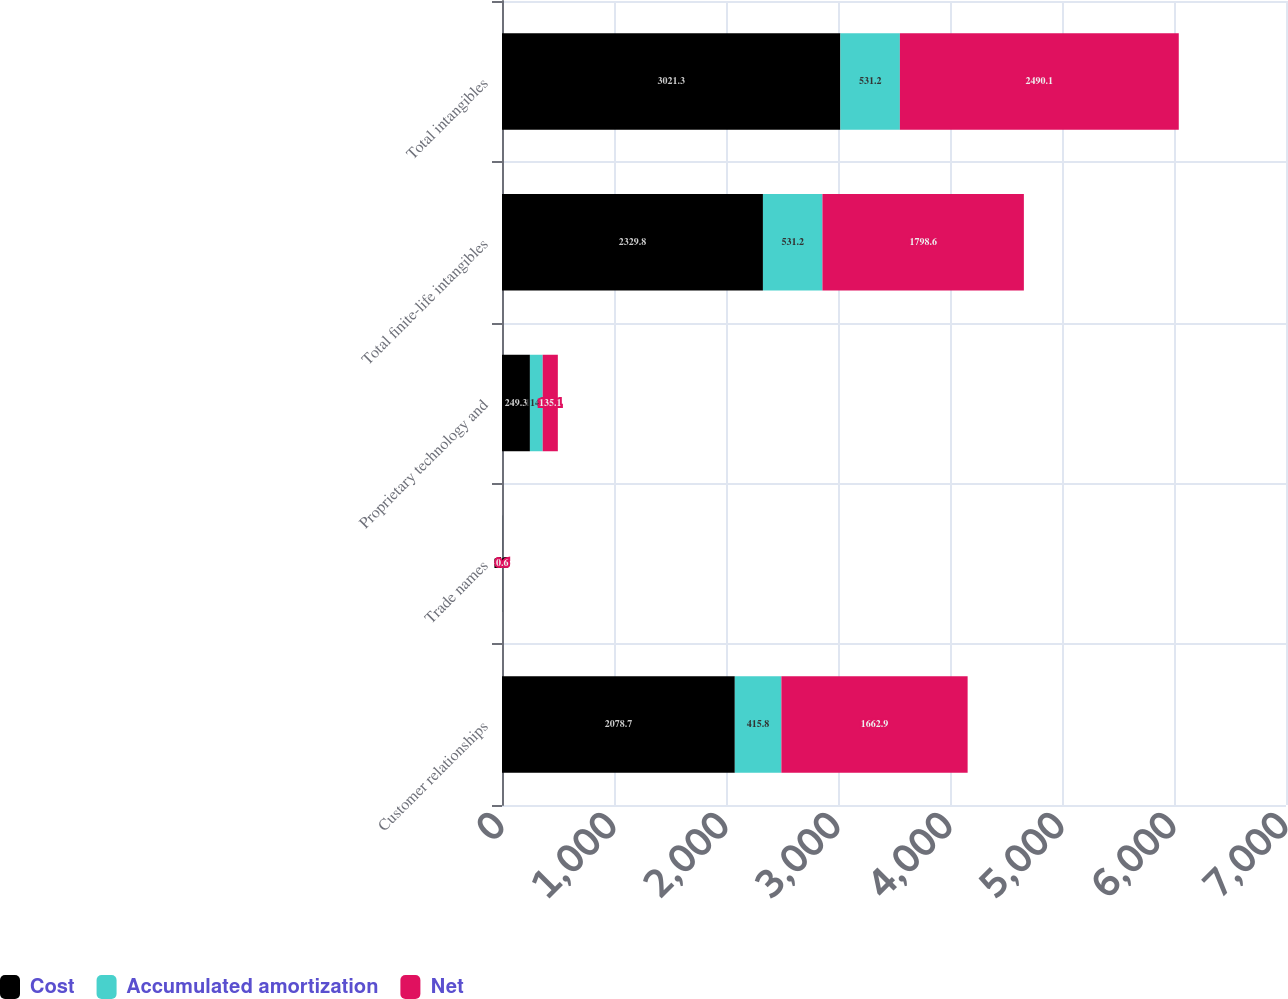Convert chart to OTSL. <chart><loc_0><loc_0><loc_500><loc_500><stacked_bar_chart><ecel><fcel>Customer relationships<fcel>Trade names<fcel>Proprietary technology and<fcel>Total finite-life intangibles<fcel>Total intangibles<nl><fcel>Cost<fcel>2078.7<fcel>1.8<fcel>249.3<fcel>2329.8<fcel>3021.3<nl><fcel>Accumulated amortization<fcel>415.8<fcel>1.2<fcel>114.2<fcel>531.2<fcel>531.2<nl><fcel>Net<fcel>1662.9<fcel>0.6<fcel>135.1<fcel>1798.6<fcel>2490.1<nl></chart> 